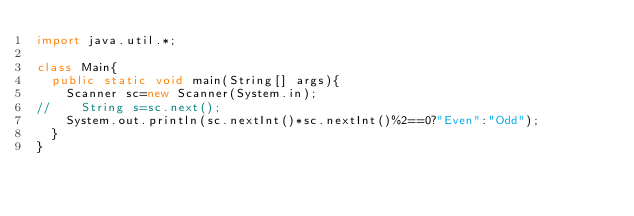<code> <loc_0><loc_0><loc_500><loc_500><_Java_>import java.util.*;

class Main{
  public static void main(String[] args){
    Scanner sc=new Scanner(System.in);
//    String s=sc.next();
    System.out.println(sc.nextInt()*sc.nextInt()%2==0?"Even":"Odd");
  }
}</code> 